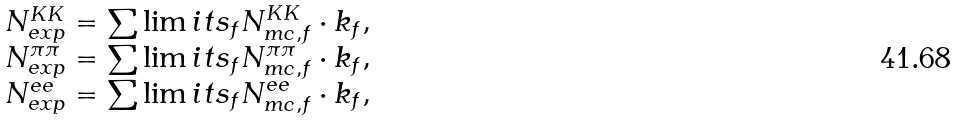Convert formula to latex. <formula><loc_0><loc_0><loc_500><loc_500>\begin{array} { l } N _ { e x p } ^ { K K } = \sum \lim i t s _ { f } N _ { m c , f } ^ { K K } \cdot k _ { f } , \\ N _ { e x p } ^ { \pi \pi } = \sum \lim i t s _ { f } N _ { m c , f } ^ { \pi \pi } \cdot k _ { f } , \\ N _ { e x p } ^ { e e } = \sum \lim i t s _ { f } N _ { m c , f } ^ { e e } \cdot k _ { f } , \\ \end{array}</formula> 